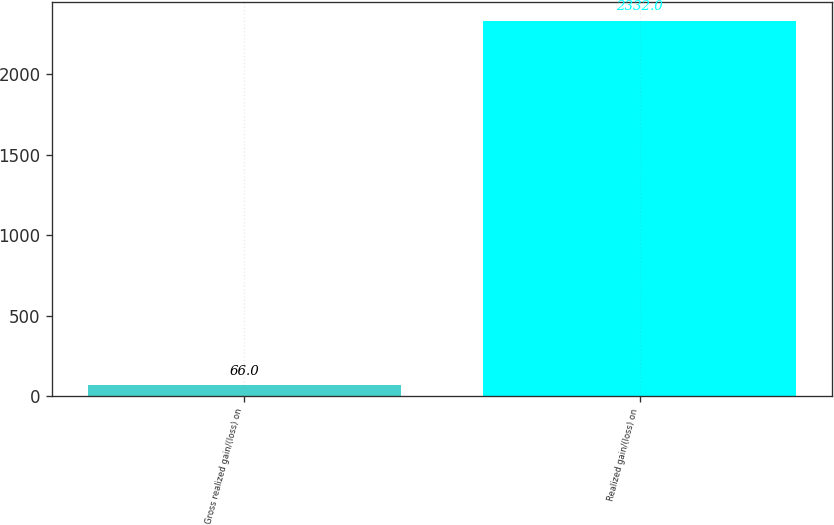<chart> <loc_0><loc_0><loc_500><loc_500><bar_chart><fcel>Gross realized gain/(loss) on<fcel>Realized gain/(loss) on<nl><fcel>66<fcel>2332<nl></chart> 